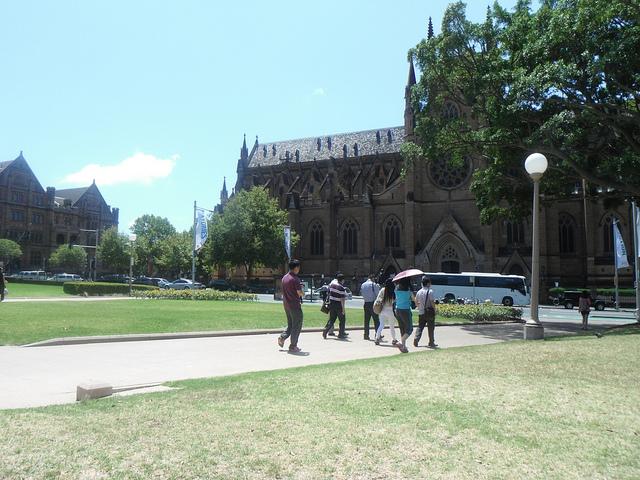Where is the light pole?
Give a very brief answer. On right. What surface is he standing on?
Quick response, please. Sidewalk. Could you trim the hedge without a ladder?
Answer briefly. Yes. Why is this person holding an umbrella?
Concise answer only. Block sun. Are they standing behind a fence?
Short answer required. No. Approximately what time of day is it based on the length of the woman's shadow?
Keep it brief. Noon. Is the light on?
Answer briefly. No. 